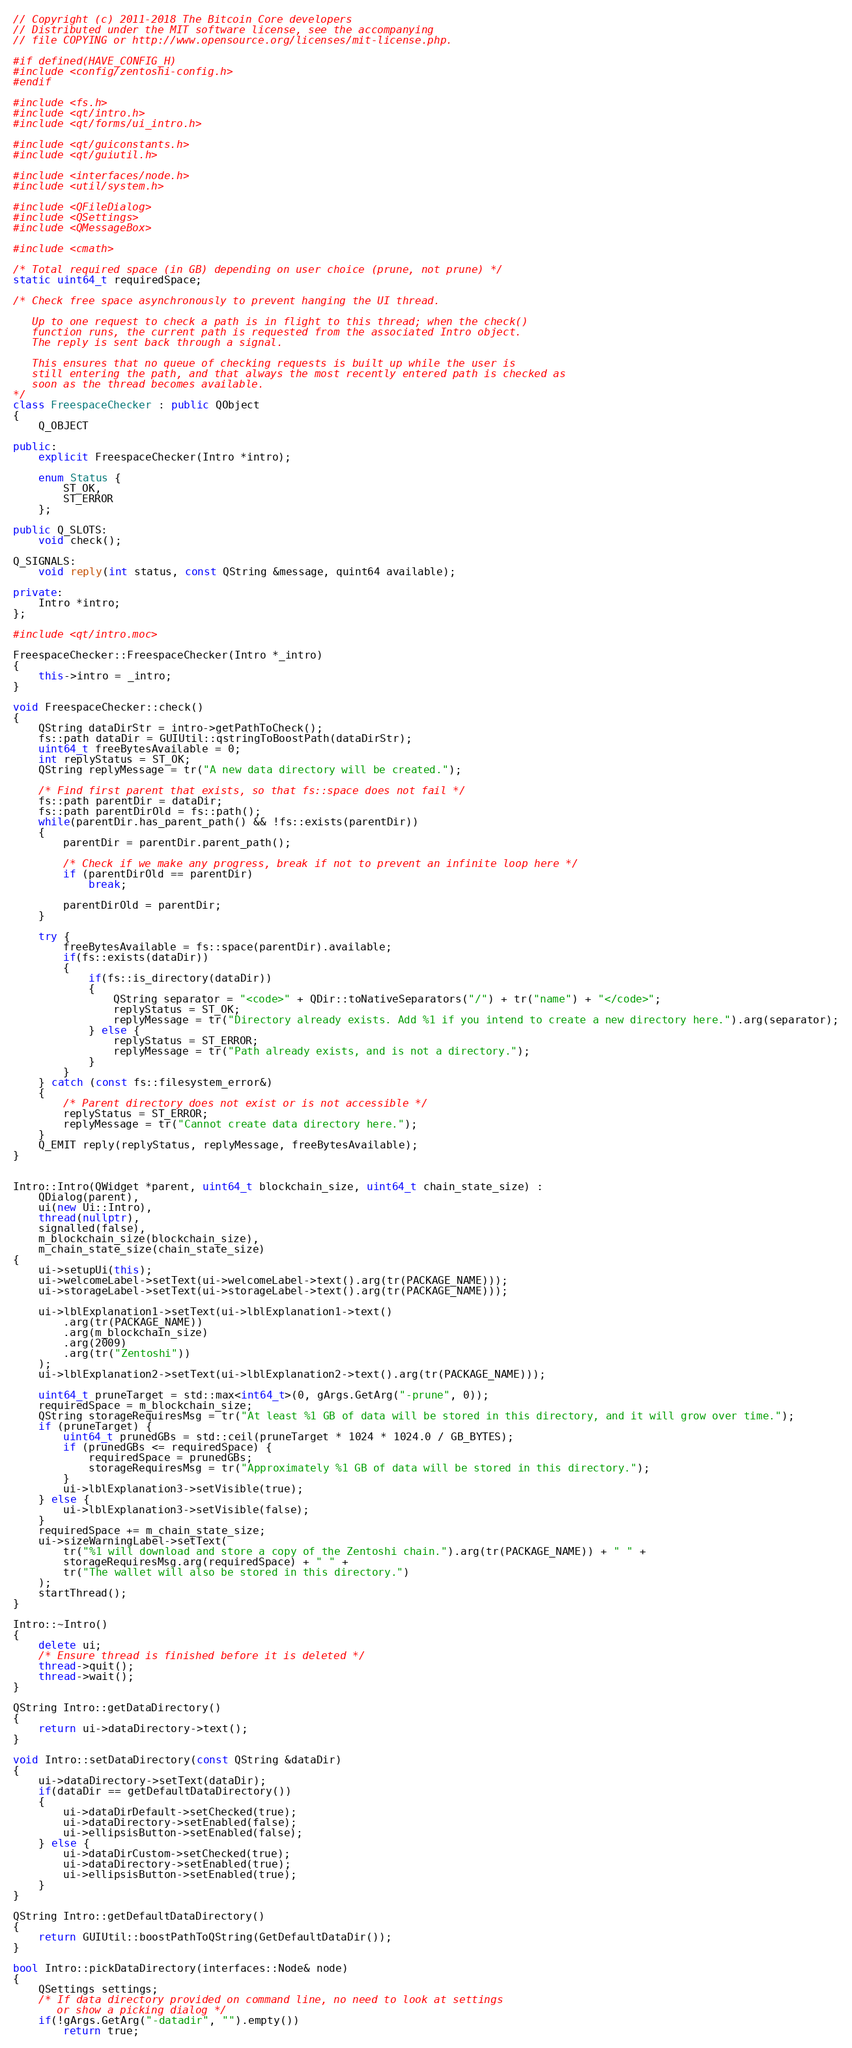<code> <loc_0><loc_0><loc_500><loc_500><_C++_>// Copyright (c) 2011-2018 The Bitcoin Core developers
// Distributed under the MIT software license, see the accompanying
// file COPYING or http://www.opensource.org/licenses/mit-license.php.

#if defined(HAVE_CONFIG_H)
#include <config/zentoshi-config.h>
#endif

#include <fs.h>
#include <qt/intro.h>
#include <qt/forms/ui_intro.h>

#include <qt/guiconstants.h>
#include <qt/guiutil.h>

#include <interfaces/node.h>
#include <util/system.h>

#include <QFileDialog>
#include <QSettings>
#include <QMessageBox>

#include <cmath>

/* Total required space (in GB) depending on user choice (prune, not prune) */
static uint64_t requiredSpace;

/* Check free space asynchronously to prevent hanging the UI thread.

   Up to one request to check a path is in flight to this thread; when the check()
   function runs, the current path is requested from the associated Intro object.
   The reply is sent back through a signal.

   This ensures that no queue of checking requests is built up while the user is
   still entering the path, and that always the most recently entered path is checked as
   soon as the thread becomes available.
*/
class FreespaceChecker : public QObject
{
    Q_OBJECT

public:
    explicit FreespaceChecker(Intro *intro);

    enum Status {
        ST_OK,
        ST_ERROR
    };

public Q_SLOTS:
    void check();

Q_SIGNALS:
    void reply(int status, const QString &message, quint64 available);

private:
    Intro *intro;
};

#include <qt/intro.moc>

FreespaceChecker::FreespaceChecker(Intro *_intro)
{
    this->intro = _intro;
}

void FreespaceChecker::check()
{
    QString dataDirStr = intro->getPathToCheck();
    fs::path dataDir = GUIUtil::qstringToBoostPath(dataDirStr);
    uint64_t freeBytesAvailable = 0;
    int replyStatus = ST_OK;
    QString replyMessage = tr("A new data directory will be created.");

    /* Find first parent that exists, so that fs::space does not fail */
    fs::path parentDir = dataDir;
    fs::path parentDirOld = fs::path();
    while(parentDir.has_parent_path() && !fs::exists(parentDir))
    {
        parentDir = parentDir.parent_path();

        /* Check if we make any progress, break if not to prevent an infinite loop here */
        if (parentDirOld == parentDir)
            break;

        parentDirOld = parentDir;
    }

    try {
        freeBytesAvailable = fs::space(parentDir).available;
        if(fs::exists(dataDir))
        {
            if(fs::is_directory(dataDir))
            {
                QString separator = "<code>" + QDir::toNativeSeparators("/") + tr("name") + "</code>";
                replyStatus = ST_OK;
                replyMessage = tr("Directory already exists. Add %1 if you intend to create a new directory here.").arg(separator);
            } else {
                replyStatus = ST_ERROR;
                replyMessage = tr("Path already exists, and is not a directory.");
            }
        }
    } catch (const fs::filesystem_error&)
    {
        /* Parent directory does not exist or is not accessible */
        replyStatus = ST_ERROR;
        replyMessage = tr("Cannot create data directory here.");
    }
    Q_EMIT reply(replyStatus, replyMessage, freeBytesAvailable);
}


Intro::Intro(QWidget *parent, uint64_t blockchain_size, uint64_t chain_state_size) :
    QDialog(parent),
    ui(new Ui::Intro),
    thread(nullptr),
    signalled(false),
    m_blockchain_size(blockchain_size),
    m_chain_state_size(chain_state_size)
{
    ui->setupUi(this);
    ui->welcomeLabel->setText(ui->welcomeLabel->text().arg(tr(PACKAGE_NAME)));
    ui->storageLabel->setText(ui->storageLabel->text().arg(tr(PACKAGE_NAME)));

    ui->lblExplanation1->setText(ui->lblExplanation1->text()
        .arg(tr(PACKAGE_NAME))
        .arg(m_blockchain_size)
        .arg(2009)
        .arg(tr("Zentoshi"))
    );
    ui->lblExplanation2->setText(ui->lblExplanation2->text().arg(tr(PACKAGE_NAME)));

    uint64_t pruneTarget = std::max<int64_t>(0, gArgs.GetArg("-prune", 0));
    requiredSpace = m_blockchain_size;
    QString storageRequiresMsg = tr("At least %1 GB of data will be stored in this directory, and it will grow over time.");
    if (pruneTarget) {
        uint64_t prunedGBs = std::ceil(pruneTarget * 1024 * 1024.0 / GB_BYTES);
        if (prunedGBs <= requiredSpace) {
            requiredSpace = prunedGBs;
            storageRequiresMsg = tr("Approximately %1 GB of data will be stored in this directory.");
        }
        ui->lblExplanation3->setVisible(true);
    } else {
        ui->lblExplanation3->setVisible(false);
    }
    requiredSpace += m_chain_state_size;
    ui->sizeWarningLabel->setText(
        tr("%1 will download and store a copy of the Zentoshi chain.").arg(tr(PACKAGE_NAME)) + " " +
        storageRequiresMsg.arg(requiredSpace) + " " +
        tr("The wallet will also be stored in this directory.")
    );
    startThread();
}

Intro::~Intro()
{
    delete ui;
    /* Ensure thread is finished before it is deleted */
    thread->quit();
    thread->wait();
}

QString Intro::getDataDirectory()
{
    return ui->dataDirectory->text();
}

void Intro::setDataDirectory(const QString &dataDir)
{
    ui->dataDirectory->setText(dataDir);
    if(dataDir == getDefaultDataDirectory())
    {
        ui->dataDirDefault->setChecked(true);
        ui->dataDirectory->setEnabled(false);
        ui->ellipsisButton->setEnabled(false);
    } else {
        ui->dataDirCustom->setChecked(true);
        ui->dataDirectory->setEnabled(true);
        ui->ellipsisButton->setEnabled(true);
    }
}

QString Intro::getDefaultDataDirectory()
{
    return GUIUtil::boostPathToQString(GetDefaultDataDir());
}

bool Intro::pickDataDirectory(interfaces::Node& node)
{
    QSettings settings;
    /* If data directory provided on command line, no need to look at settings
       or show a picking dialog */
    if(!gArgs.GetArg("-datadir", "").empty())
        return true;</code> 